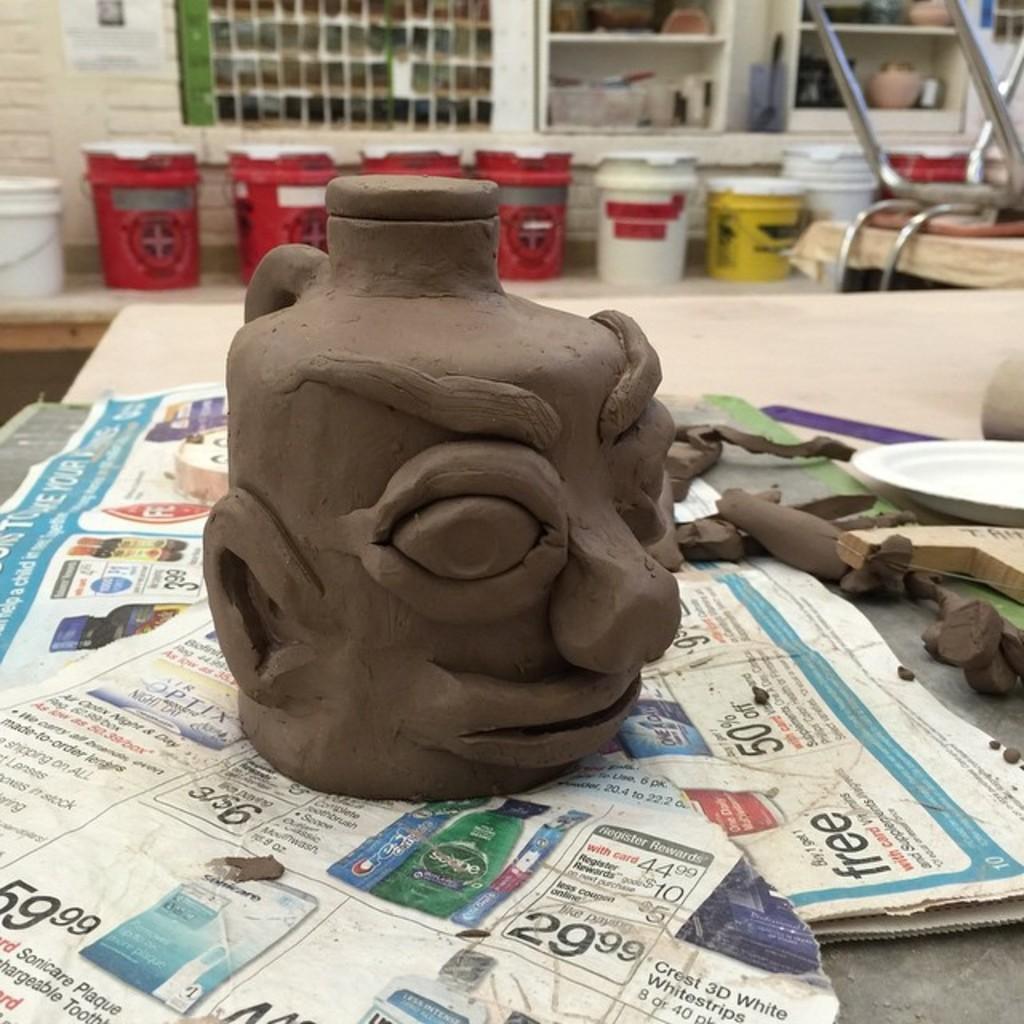In one or two sentences, can you explain what this image depicts? Here I can see a clay toy. It is placed on the papers, these papers are placed on a table. On the right side there is a plate and some objects. In the background there are few buckets placed on a bench, behind there is a wall and also I can see few racks in which some objects are placed. In the top right there is a metal object. 